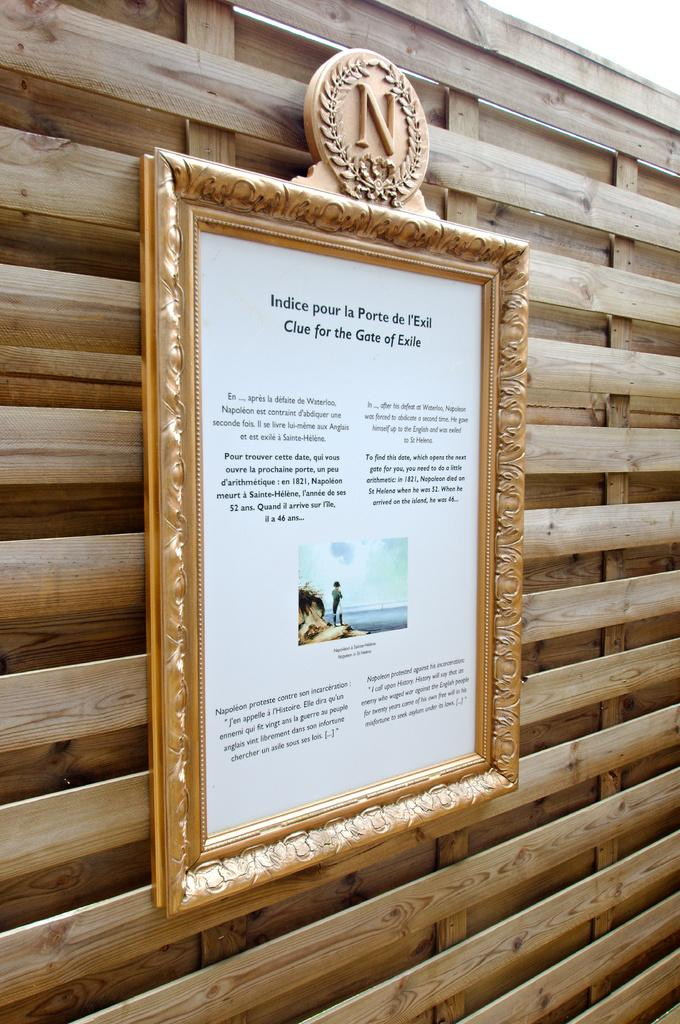<image>
Relay a brief, clear account of the picture shown. A frame with a picture and text that says Indice pour la Porte is on a wooden wall. 